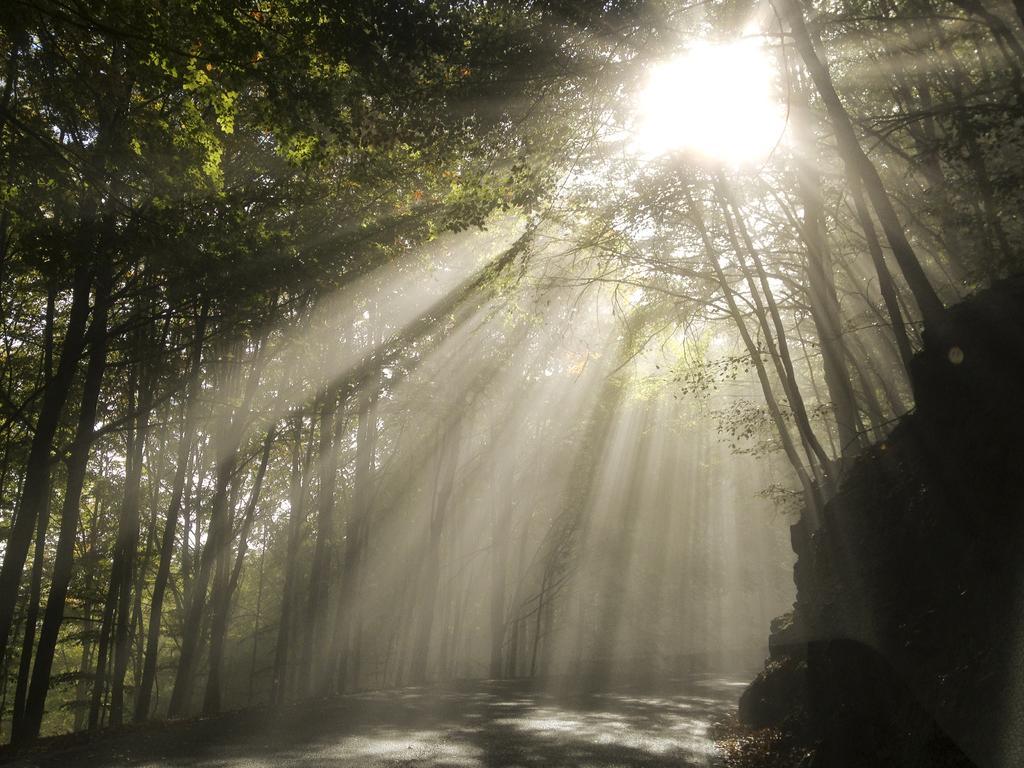How would you summarize this image in a sentence or two? In the center of the image there is a road. On the left side of the image there are rocks. There are trees. In the background of the image there is sun. 